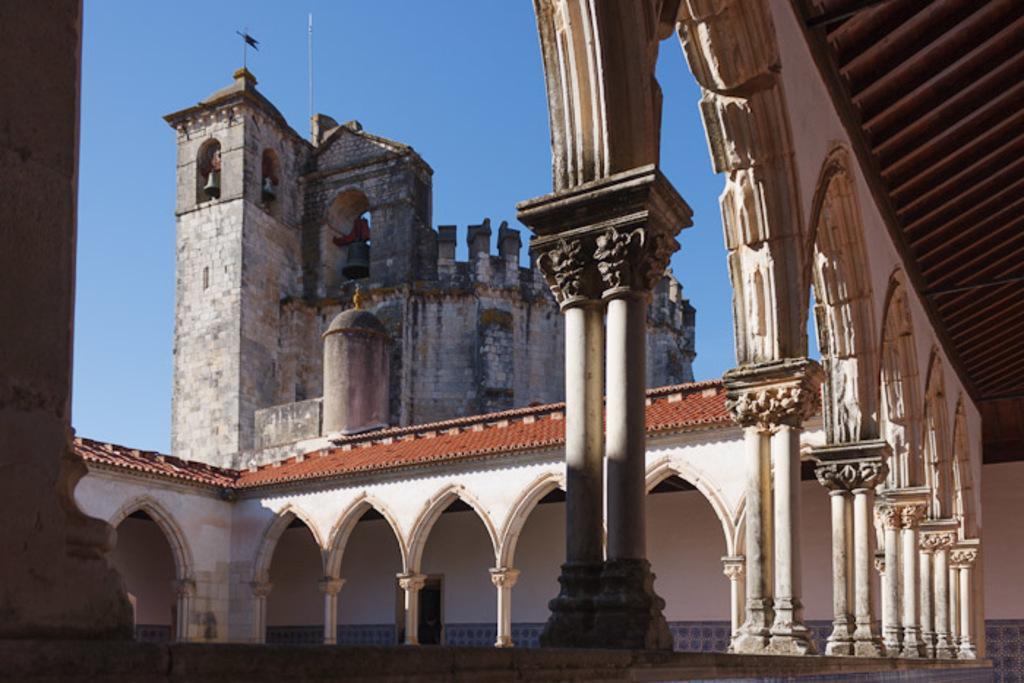How would you summarize this image in a sentence or two? In this image we can see a view of a building. At the top we can see the sky. There is also a pole in this image. 